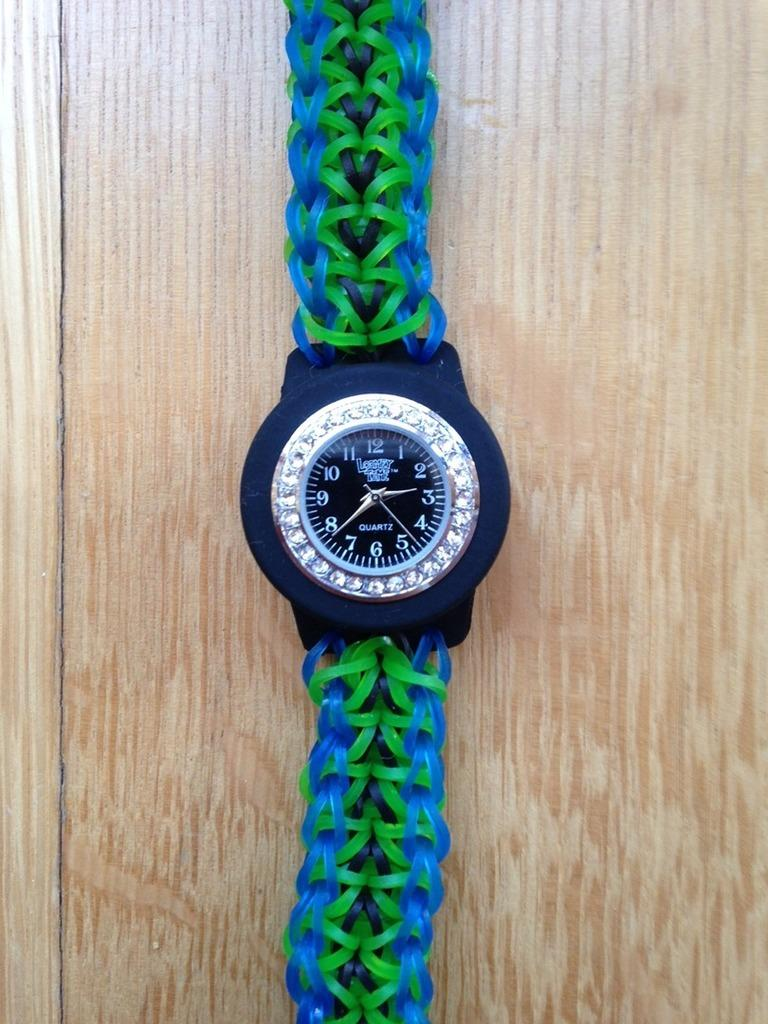<image>
Share a concise interpretation of the image provided. A watch with a green and blue band and on the watch face it says Quartz. 